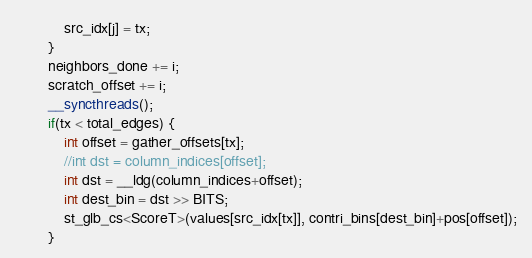Convert code to text. <code><loc_0><loc_0><loc_500><loc_500><_Cuda_>			src_idx[j] = tx;
		}
		neighbors_done += i;
		scratch_offset += i;
		__syncthreads();
		if(tx < total_edges) {
			int offset = gather_offsets[tx];
			//int dst = column_indices[offset];
			int dst = __ldg(column_indices+offset);
			int dest_bin = dst >> BITS;
			st_glb_cs<ScoreT>(values[src_idx[tx]], contri_bins[dest_bin]+pos[offset]);
		}</code> 